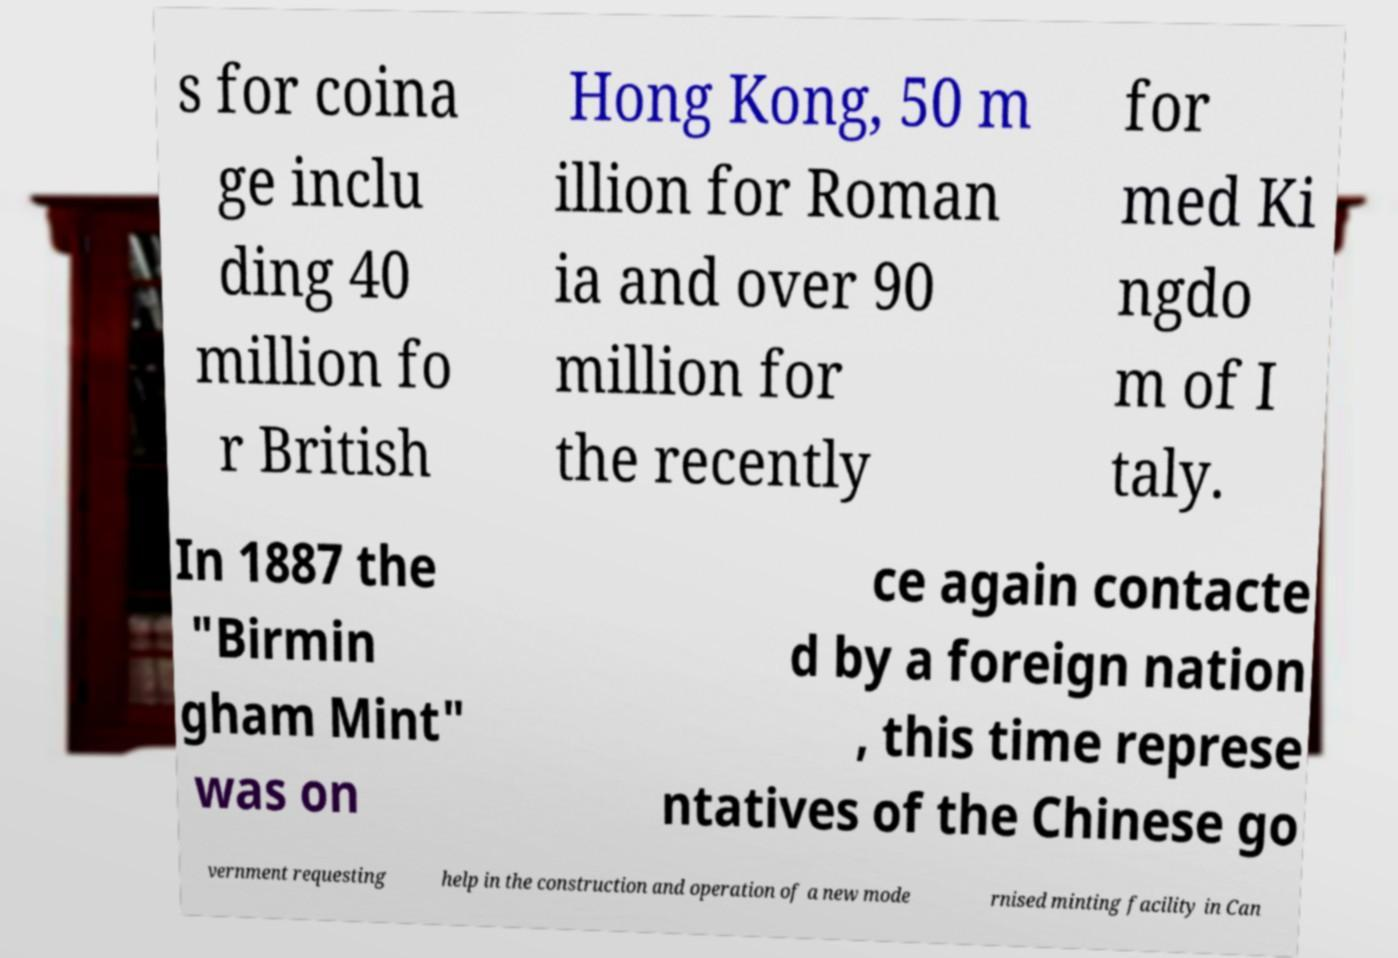Please read and relay the text visible in this image. What does it say? s for coina ge inclu ding 40 million fo r British Hong Kong, 50 m illion for Roman ia and over 90 million for the recently for med Ki ngdo m of I taly. In 1887 the "Birmin gham Mint" was on ce again contacte d by a foreign nation , this time represe ntatives of the Chinese go vernment requesting help in the construction and operation of a new mode rnised minting facility in Can 